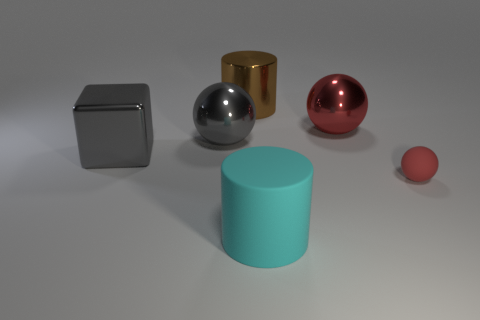Subtract all big gray metal spheres. How many spheres are left? 2 Add 3 cyan shiny balls. How many objects exist? 9 Subtract all gray balls. How many balls are left? 2 Subtract all cylinders. How many objects are left? 4 Subtract 1 cylinders. How many cylinders are left? 1 Add 5 red objects. How many red objects exist? 7 Subtract 0 purple cylinders. How many objects are left? 6 Subtract all green balls. Subtract all green blocks. How many balls are left? 3 Subtract all purple spheres. How many cyan cylinders are left? 1 Subtract all large gray things. Subtract all brown metallic cylinders. How many objects are left? 3 